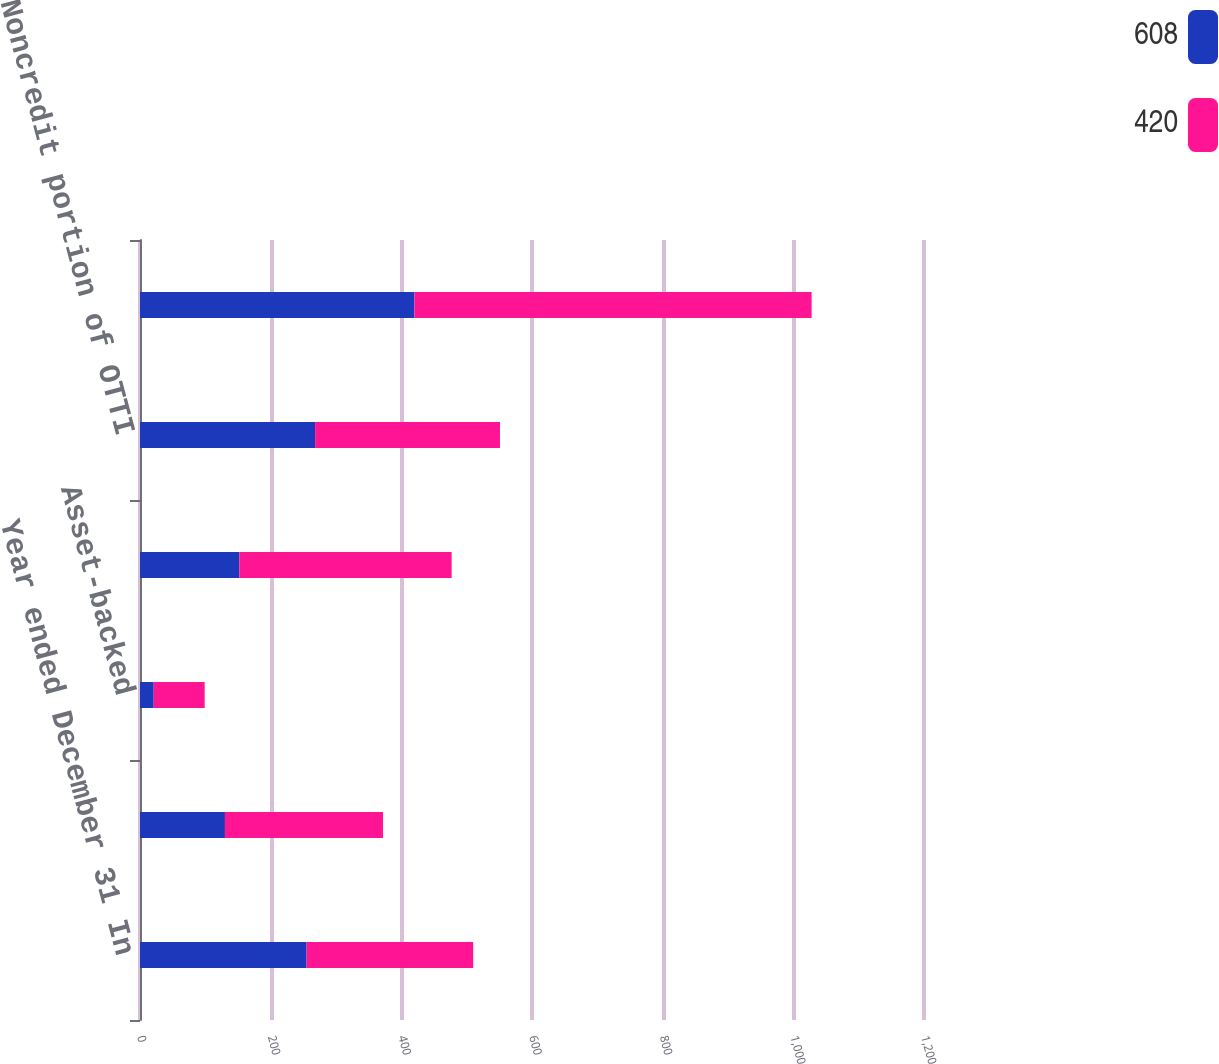Convert chart. <chart><loc_0><loc_0><loc_500><loc_500><stacked_bar_chart><ecel><fcel>Year ended December 31 In<fcel>Non-agency residential<fcel>Asset-backed<fcel>Total credit portion of OTTI<fcel>Noncredit portion of OTTI<fcel>Total OTTI losses<nl><fcel>608<fcel>255<fcel>130<fcel>21<fcel>152<fcel>268<fcel>420<nl><fcel>420<fcel>255<fcel>242<fcel>78<fcel>325<fcel>283<fcel>608<nl></chart> 